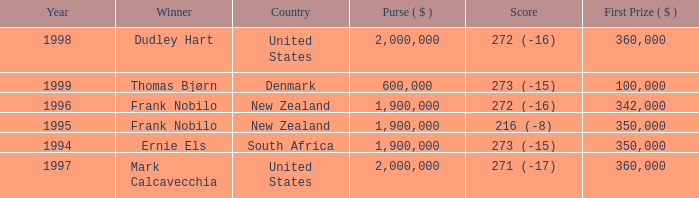What was the total purse in the years after 1996 with a score of 272 (-16) when frank nobilo won? None. 